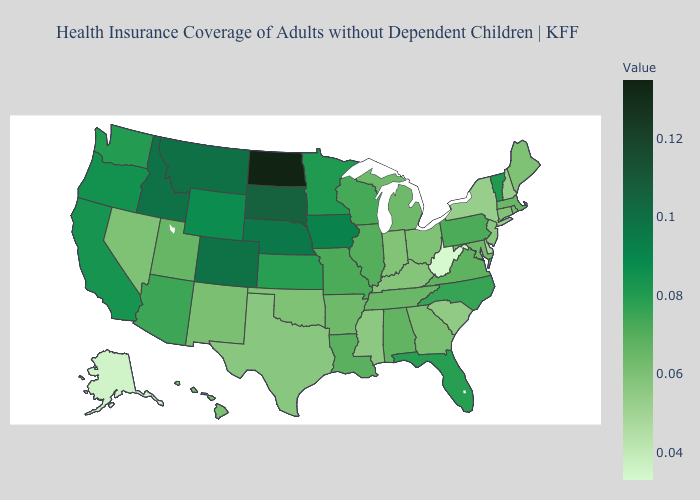Among the states that border Delaware , does Pennsylvania have the lowest value?
Quick response, please. No. Among the states that border Washington , which have the lowest value?
Quick response, please. Oregon. Which states have the lowest value in the USA?
Write a very short answer. West Virginia. Does the map have missing data?
Quick response, please. No. Which states have the lowest value in the South?
Quick response, please. West Virginia. Which states have the lowest value in the West?
Quick response, please. Alaska. Does Alaska have the highest value in the USA?
Short answer required. No. 